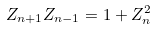<formula> <loc_0><loc_0><loc_500><loc_500>Z _ { n + 1 } Z _ { n - 1 } = 1 + Z ^ { 2 } _ { n }</formula> 